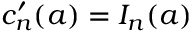<formula> <loc_0><loc_0><loc_500><loc_500>c _ { n } ^ { \prime } ( a ) = I _ { n } ( a )</formula> 